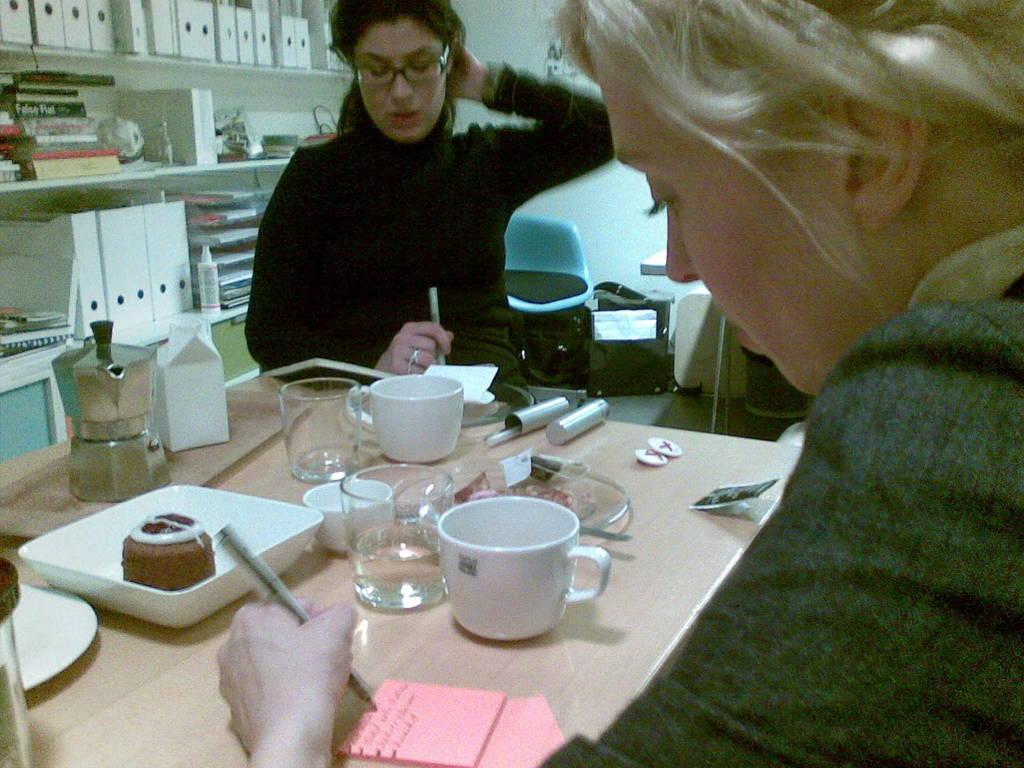Describe this image in one or two sentences. In this picture, here we can see a lady who is looking at writing something on book and at the right we have another lady who is reading something present on the paper. In front of her there is a table on which tea cup, glasses, plates, cake etc are present. In the background we have shelf in which some books, files are present. It seems like an office place. 